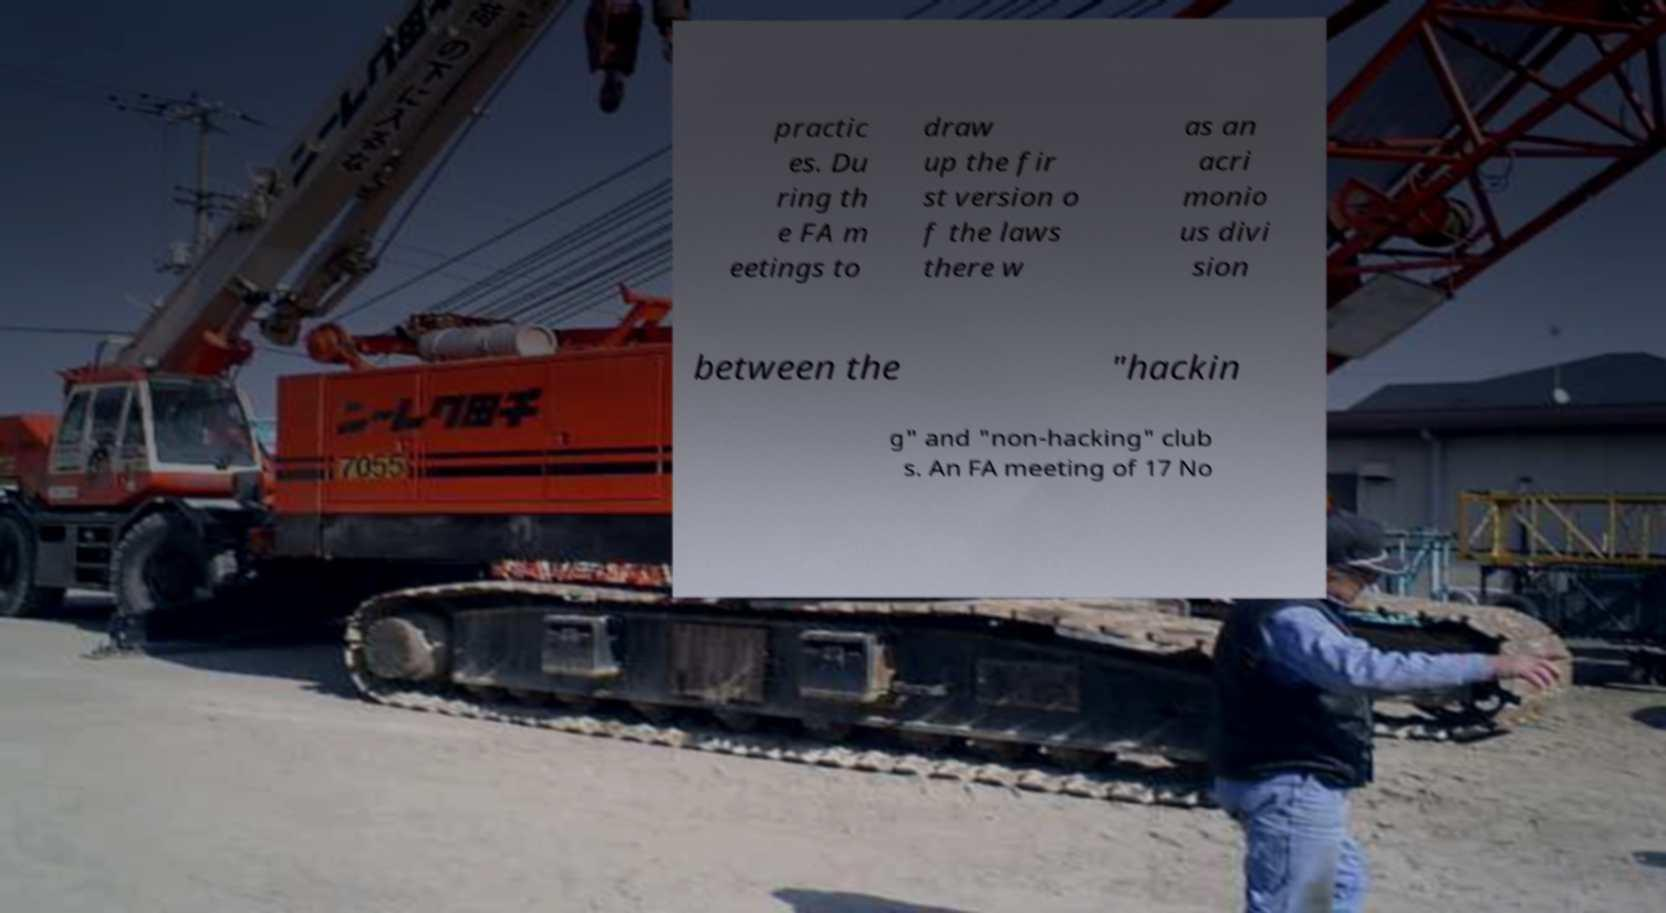There's text embedded in this image that I need extracted. Can you transcribe it verbatim? practic es. Du ring th e FA m eetings to draw up the fir st version o f the laws there w as an acri monio us divi sion between the "hackin g" and "non-hacking" club s. An FA meeting of 17 No 